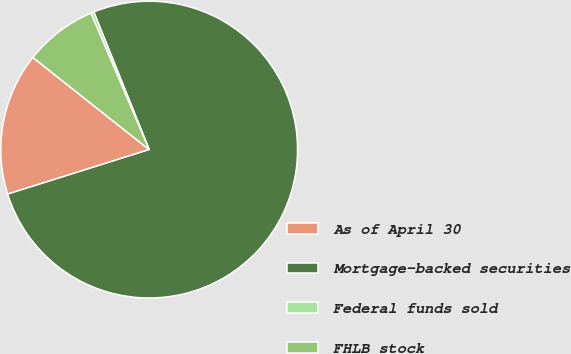Convert chart to OTSL. <chart><loc_0><loc_0><loc_500><loc_500><pie_chart><fcel>As of April 30<fcel>Mortgage-backed securities<fcel>Federal funds sold<fcel>FHLB stock<nl><fcel>15.51%<fcel>76.24%<fcel>0.33%<fcel>7.92%<nl></chart> 